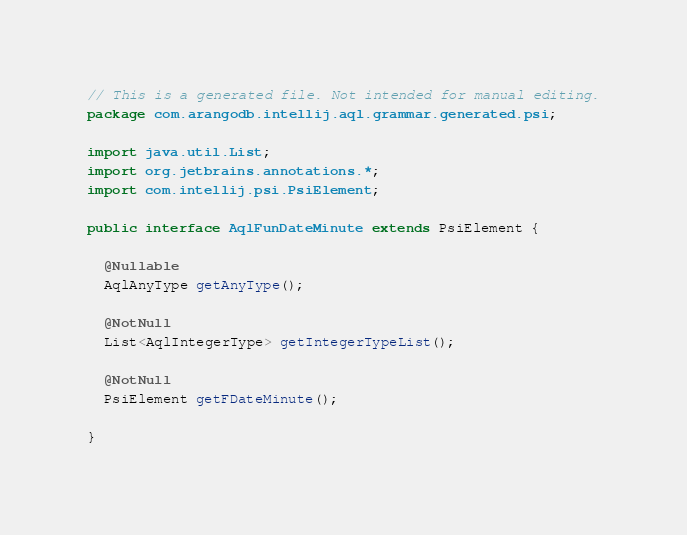Convert code to text. <code><loc_0><loc_0><loc_500><loc_500><_Java_>// This is a generated file. Not intended for manual editing.
package com.arangodb.intellij.aql.grammar.generated.psi;

import java.util.List;
import org.jetbrains.annotations.*;
import com.intellij.psi.PsiElement;

public interface AqlFunDateMinute extends PsiElement {

  @Nullable
  AqlAnyType getAnyType();

  @NotNull
  List<AqlIntegerType> getIntegerTypeList();

  @NotNull
  PsiElement getFDateMinute();

}
</code> 